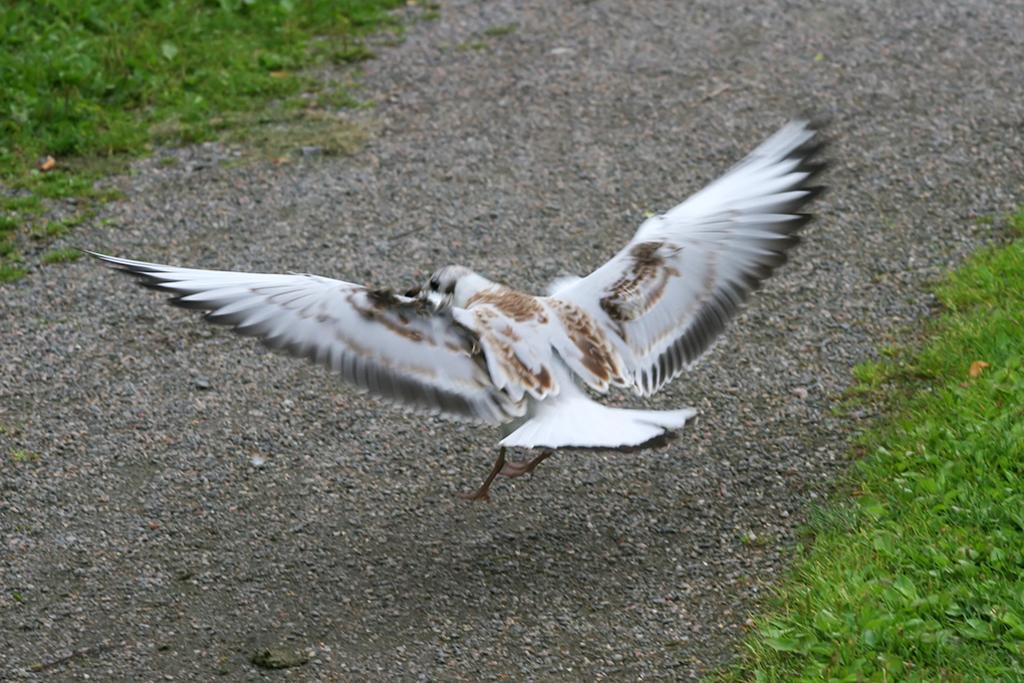Can you describe this image briefly? In the picture we can see a path on it, we can see a bird flying and trying to sit on it and the bird is white in color and on the either sides of the path we can see grass surface. 